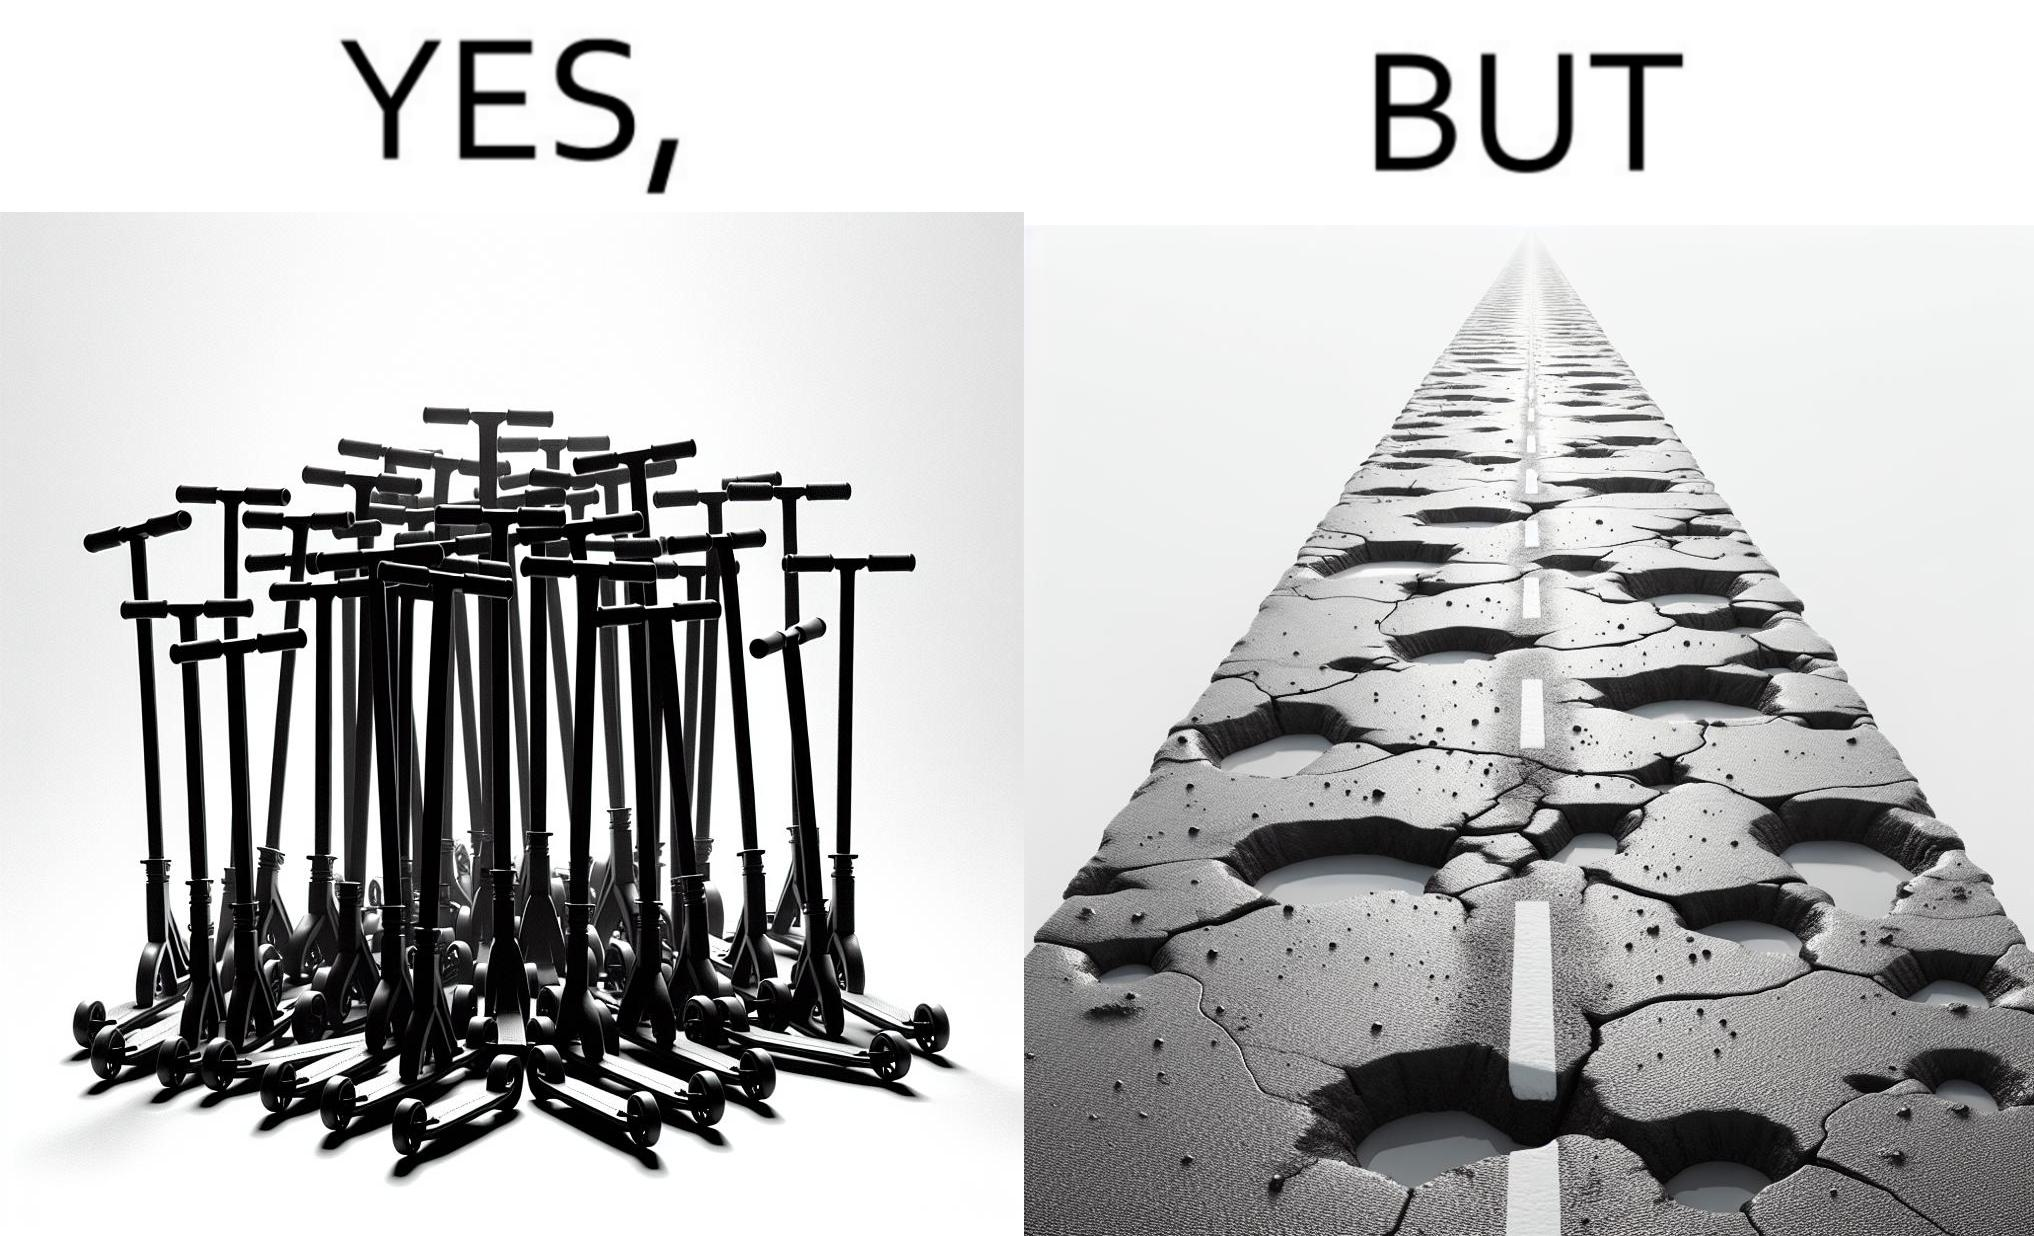Why is this image considered satirical? The image is ironic, because even after when the skateboard scooters are available for someone to ride but the road has many potholes that it is not suitable to ride the scooters on such roads 